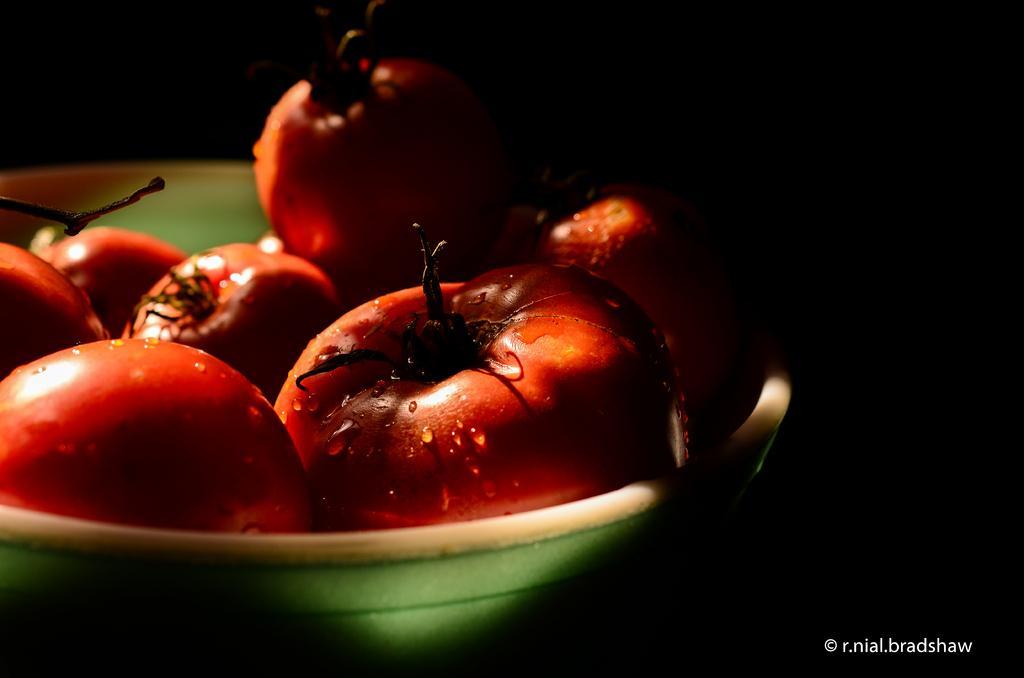How would you summarize this image in a sentence or two? In this picture I can see tomatoes in a bowl, there is dark background and there is a watermark on the image. 